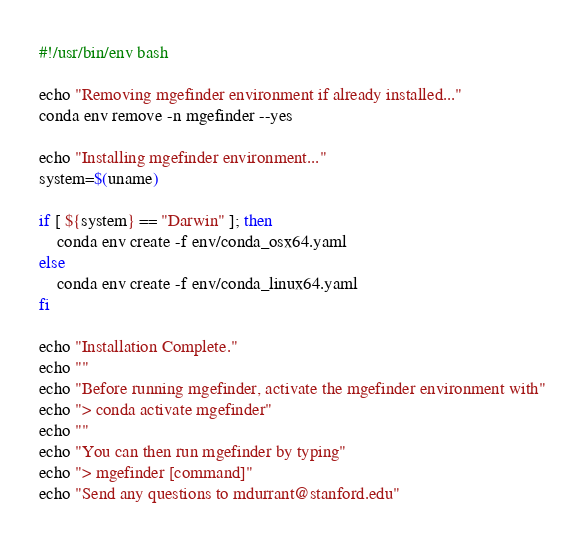Convert code to text. <code><loc_0><loc_0><loc_500><loc_500><_Bash_>#!/usr/bin/env bash

echo "Removing mgefinder environment if already installed..."
conda env remove -n mgefinder --yes

echo "Installing mgefinder environment..."
system=$(uname)

if [ ${system} == "Darwin" ]; then
	conda env create -f env/conda_osx64.yaml
else
	conda env create -f env/conda_linux64.yaml
fi

echo "Installation Complete."
echo ""
echo "Before running mgefinder, activate the mgefinder environment with"
echo "> conda activate mgefinder"
echo ""
echo "You can then run mgefinder by typing"
echo "> mgefinder [command]"
echo "Send any questions to mdurrant@stanford.edu"
</code> 